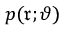Convert formula to latex. <formula><loc_0><loc_0><loc_500><loc_500>p ( \mathfrak { r } ; \vartheta )</formula> 